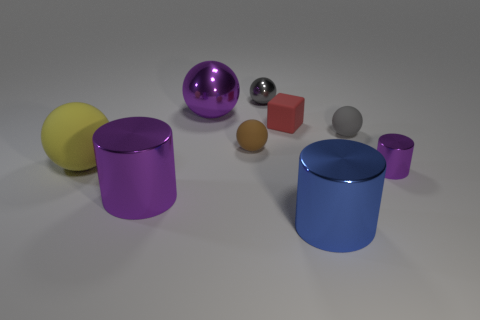There is another big object that is the same shape as the big blue metal object; what material is it?
Offer a terse response. Metal. There is a tiny purple object; is its shape the same as the big purple shiny object that is behind the small brown rubber thing?
Your answer should be compact. No. There is a tiny metal object behind the purple cylinder that is to the right of the big shiny thing to the right of the small brown object; what color is it?
Provide a succinct answer. Gray. Are there any other things that are made of the same material as the big purple ball?
Provide a short and direct response. Yes. Is the shape of the big thing right of the brown matte sphere the same as  the small brown object?
Provide a succinct answer. No. What is the blue object made of?
Provide a succinct answer. Metal. The tiny brown matte thing that is in front of the gray ball in front of the tiny shiny object behind the large yellow rubber thing is what shape?
Keep it short and to the point. Sphere. What number of other things are there of the same shape as the gray shiny object?
Provide a succinct answer. 4. There is a big matte ball; does it have the same color as the tiny ball that is behind the gray rubber object?
Your answer should be very brief. No. How many small green metal blocks are there?
Make the answer very short. 0. 